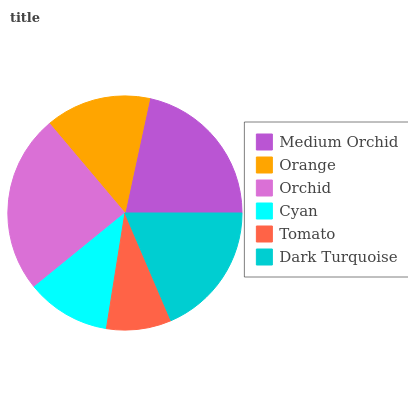Is Tomato the minimum?
Answer yes or no. Yes. Is Orchid the maximum?
Answer yes or no. Yes. Is Orange the minimum?
Answer yes or no. No. Is Orange the maximum?
Answer yes or no. No. Is Medium Orchid greater than Orange?
Answer yes or no. Yes. Is Orange less than Medium Orchid?
Answer yes or no. Yes. Is Orange greater than Medium Orchid?
Answer yes or no. No. Is Medium Orchid less than Orange?
Answer yes or no. No. Is Dark Turquoise the high median?
Answer yes or no. Yes. Is Orange the low median?
Answer yes or no. Yes. Is Orange the high median?
Answer yes or no. No. Is Cyan the low median?
Answer yes or no. No. 